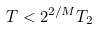Convert formula to latex. <formula><loc_0><loc_0><loc_500><loc_500>T < 2 ^ { 2 / M } T _ { 2 }</formula> 